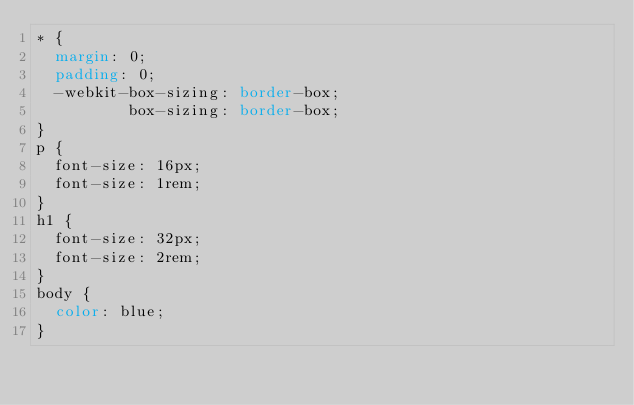Convert code to text. <code><loc_0><loc_0><loc_500><loc_500><_CSS_>* {
  margin: 0;
  padding: 0;
  -webkit-box-sizing: border-box;
          box-sizing: border-box;
}
p {
  font-size: 16px;
  font-size: 1rem;
}
h1 {
  font-size: 32px;
  font-size: 2rem;
}
body {
  color: blue;
}

</code> 